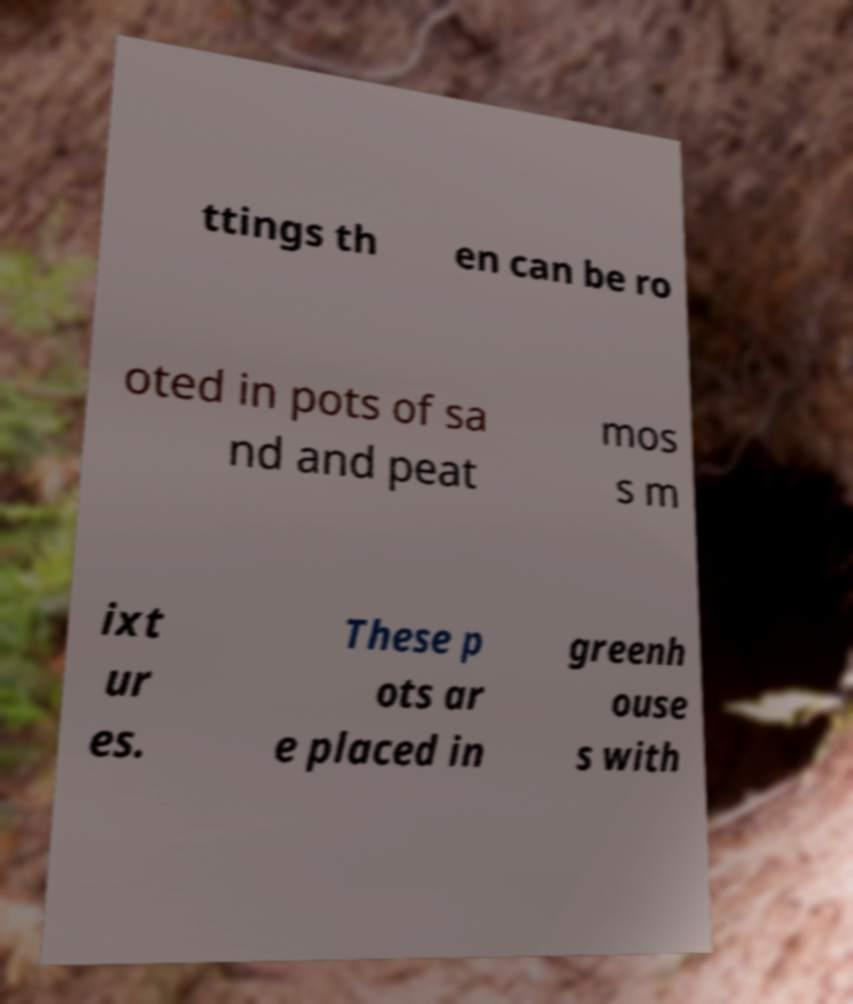Please read and relay the text visible in this image. What does it say? ttings th en can be ro oted in pots of sa nd and peat mos s m ixt ur es. These p ots ar e placed in greenh ouse s with 